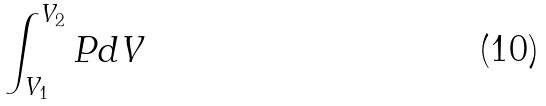Convert formula to latex. <formula><loc_0><loc_0><loc_500><loc_500>\int _ { V _ { 1 } } ^ { V _ { 2 } } P d V</formula> 